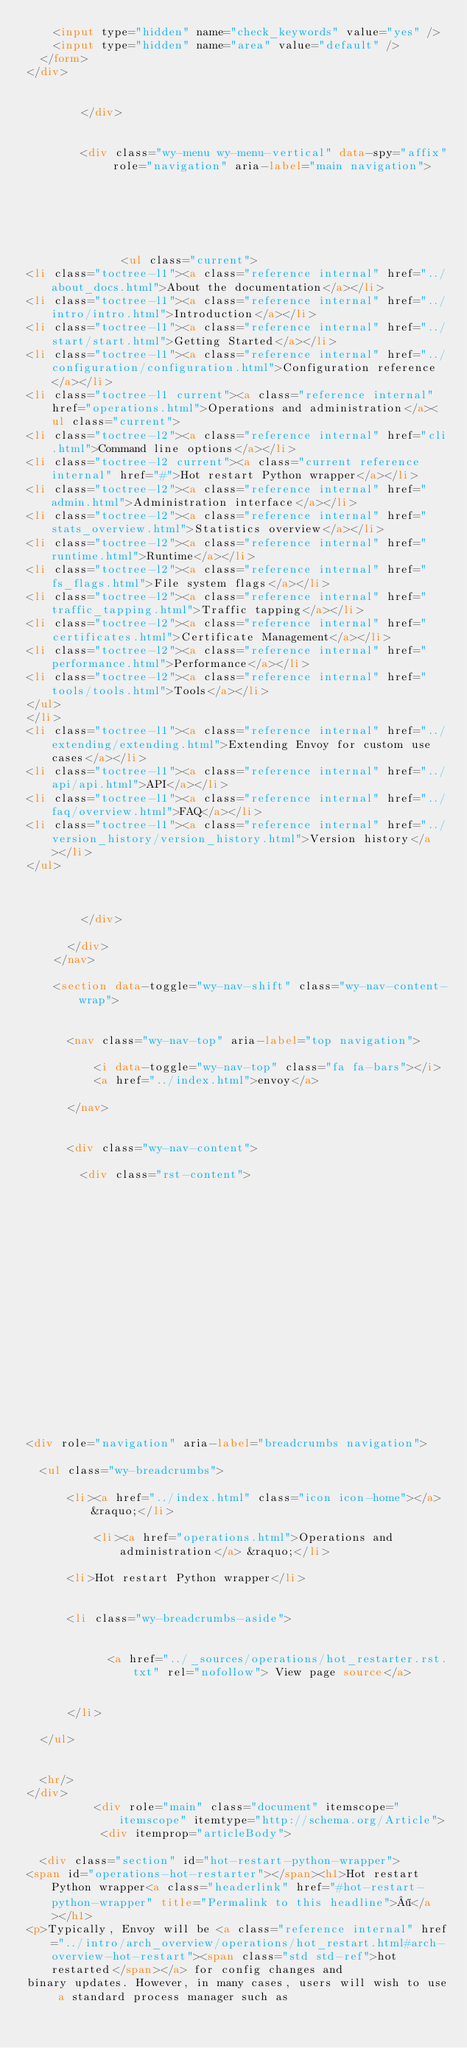Convert code to text. <code><loc_0><loc_0><loc_500><loc_500><_HTML_>    <input type="hidden" name="check_keywords" value="yes" />
    <input type="hidden" name="area" value="default" />
  </form>
</div>

          
        </div>

        
        <div class="wy-menu wy-menu-vertical" data-spy="affix" role="navigation" aria-label="main navigation">
          
            
            
              
            
            
              <ul class="current">
<li class="toctree-l1"><a class="reference internal" href="../about_docs.html">About the documentation</a></li>
<li class="toctree-l1"><a class="reference internal" href="../intro/intro.html">Introduction</a></li>
<li class="toctree-l1"><a class="reference internal" href="../start/start.html">Getting Started</a></li>
<li class="toctree-l1"><a class="reference internal" href="../configuration/configuration.html">Configuration reference</a></li>
<li class="toctree-l1 current"><a class="reference internal" href="operations.html">Operations and administration</a><ul class="current">
<li class="toctree-l2"><a class="reference internal" href="cli.html">Command line options</a></li>
<li class="toctree-l2 current"><a class="current reference internal" href="#">Hot restart Python wrapper</a></li>
<li class="toctree-l2"><a class="reference internal" href="admin.html">Administration interface</a></li>
<li class="toctree-l2"><a class="reference internal" href="stats_overview.html">Statistics overview</a></li>
<li class="toctree-l2"><a class="reference internal" href="runtime.html">Runtime</a></li>
<li class="toctree-l2"><a class="reference internal" href="fs_flags.html">File system flags</a></li>
<li class="toctree-l2"><a class="reference internal" href="traffic_tapping.html">Traffic tapping</a></li>
<li class="toctree-l2"><a class="reference internal" href="certificates.html">Certificate Management</a></li>
<li class="toctree-l2"><a class="reference internal" href="performance.html">Performance</a></li>
<li class="toctree-l2"><a class="reference internal" href="tools/tools.html">Tools</a></li>
</ul>
</li>
<li class="toctree-l1"><a class="reference internal" href="../extending/extending.html">Extending Envoy for custom use cases</a></li>
<li class="toctree-l1"><a class="reference internal" href="../api/api.html">API</a></li>
<li class="toctree-l1"><a class="reference internal" href="../faq/overview.html">FAQ</a></li>
<li class="toctree-l1"><a class="reference internal" href="../version_history/version_history.html">Version history</a></li>
</ul>

            
          
        </div>
        
      </div>
    </nav>

    <section data-toggle="wy-nav-shift" class="wy-nav-content-wrap">

      
      <nav class="wy-nav-top" aria-label="top navigation">
        
          <i data-toggle="wy-nav-top" class="fa fa-bars"></i>
          <a href="../index.html">envoy</a>
        
      </nav>


      <div class="wy-nav-content">
        
        <div class="rst-content">
        
          

















<div role="navigation" aria-label="breadcrumbs navigation">

  <ul class="wy-breadcrumbs">
    
      <li><a href="../index.html" class="icon icon-home"></a> &raquo;</li>
        
          <li><a href="operations.html">Operations and administration</a> &raquo;</li>
        
      <li>Hot restart Python wrapper</li>
    
    
      <li class="wy-breadcrumbs-aside">
        
          
            <a href="../_sources/operations/hot_restarter.rst.txt" rel="nofollow"> View page source</a>
          
        
      </li>
    
  </ul>

  
  <hr/>
</div>
          <div role="main" class="document" itemscope="itemscope" itemtype="http://schema.org/Article">
           <div itemprop="articleBody">
            
  <div class="section" id="hot-restart-python-wrapper">
<span id="operations-hot-restarter"></span><h1>Hot restart Python wrapper<a class="headerlink" href="#hot-restart-python-wrapper" title="Permalink to this headline">¶</a></h1>
<p>Typically, Envoy will be <a class="reference internal" href="../intro/arch_overview/operations/hot_restart.html#arch-overview-hot-restart"><span class="std std-ref">hot restarted</span></a> for config changes and
binary updates. However, in many cases, users will wish to use a standard process manager such as</code> 